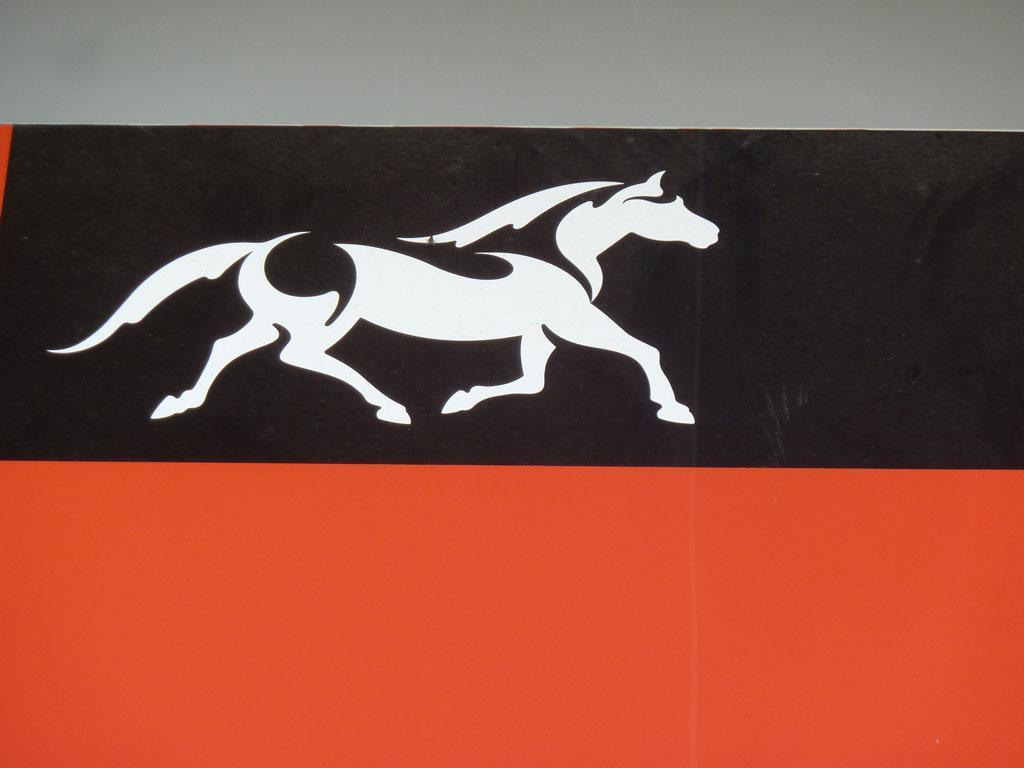What is depicted in the image? There is a logo of an animal in the image. What color is the surface behind the logo? The surface behind the logo is black. What type of farm can be seen in the image? There is no farm present in the image; it only features a logo of an animal on a black surface. What part of the animal's flesh is visible in the image? There is no flesh visible in the image, as it only features a logo of an animal on a black surface. 